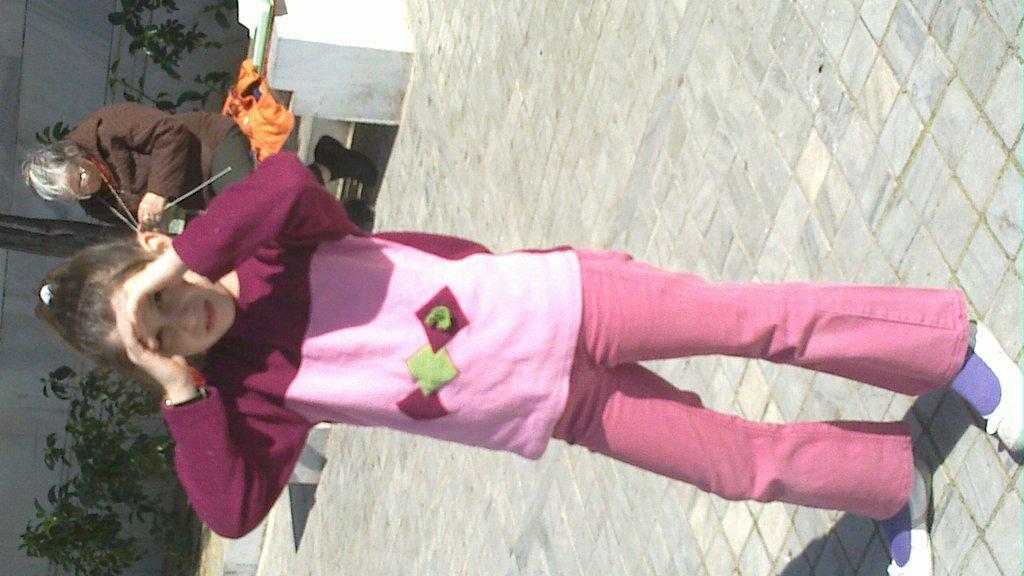How would you summarize this image in a sentence or two? In the picture we can see a girl child standing on the path and keeping her hands on the forehead and in the background, we can see a person sitting on the bench and behind her we can see some plants and a wall. 